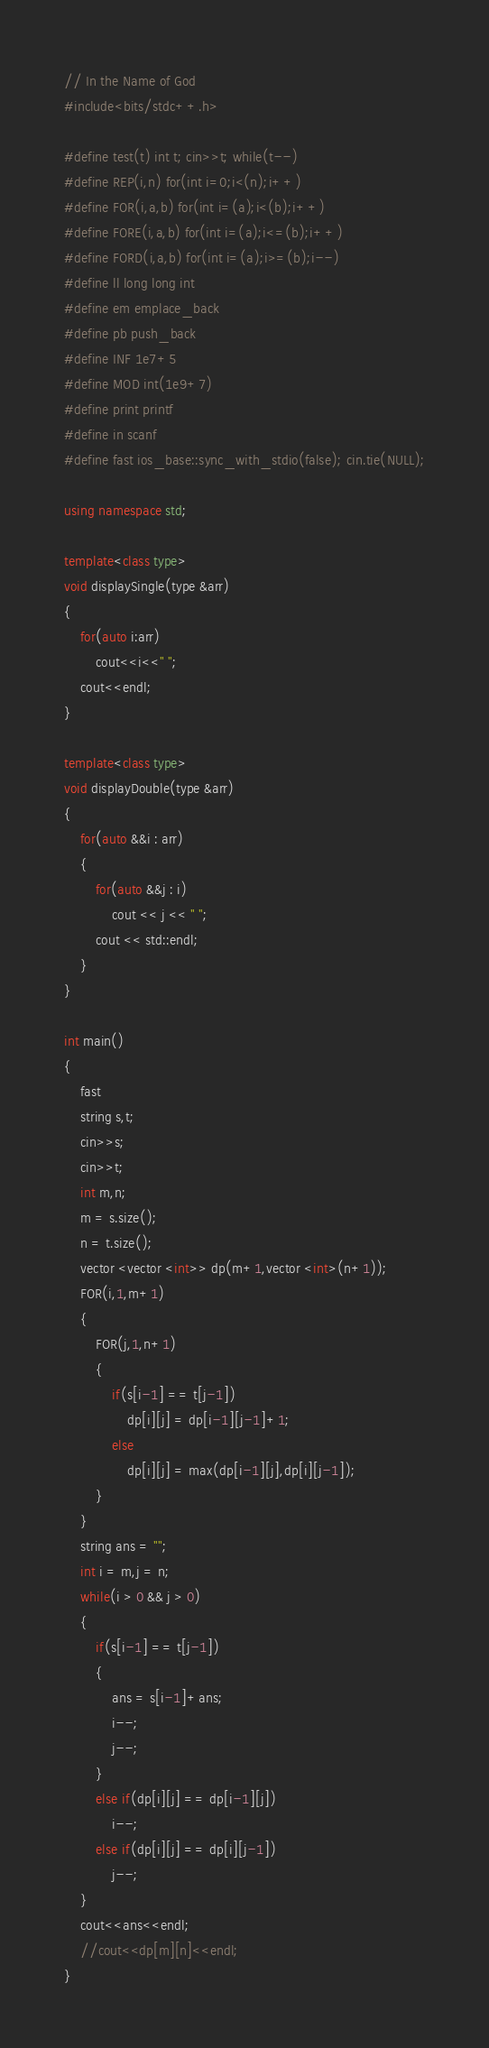<code> <loc_0><loc_0><loc_500><loc_500><_C++_>// In the Name of God
#include<bits/stdc++.h>

#define test(t) int t; cin>>t; while(t--)
#define REP(i,n) for(int i=0;i<(n);i++)
#define FOR(i,a,b) for(int i=(a);i<(b);i++)
#define FORE(i,a,b) for(int i=(a);i<=(b);i++)
#define FORD(i,a,b) for(int i=(a);i>=(b);i--)
#define ll long long int
#define em emplace_back
#define pb push_back
#define INF 1e7+5
#define MOD int(1e9+7)
#define print printf
#define in scanf
#define fast ios_base::sync_with_stdio(false); cin.tie(NULL);

using namespace std;

template<class type>
void displaySingle(type &arr)
{
	for(auto i:arr)
		cout<<i<<" ";
	cout<<endl;
}

template<class type>
void displayDouble(type &arr)
{
	for(auto &&i : arr) 
	{
		for(auto &&j : i) 
			cout << j << " ";
		cout << std::endl;
	}
}

int main()
{
	fast
	string s,t;
	cin>>s;
	cin>>t;
	int m,n;
	m = s.size();
	n = t.size();
	vector <vector <int>> dp(m+1,vector <int>(n+1));
	FOR(i,1,m+1)
	{
		FOR(j,1,n+1)
		{
			if(s[i-1] == t[j-1])
				dp[i][j] = dp[i-1][j-1]+1;
			else
				dp[i][j] = max(dp[i-1][j],dp[i][j-1]);
		}
	}
	string ans = "";
	int i = m,j = n;
	while(i > 0 && j > 0)
	{
		if(s[i-1] == t[j-1])
		{
			ans = s[i-1]+ans;
			i--;
			j--;
		}
		else if(dp[i][j] == dp[i-1][j])
			i--;
		else if(dp[i][j] == dp[i][j-1])
			j--;
	}
	cout<<ans<<endl;
	//cout<<dp[m][n]<<endl;
}</code> 